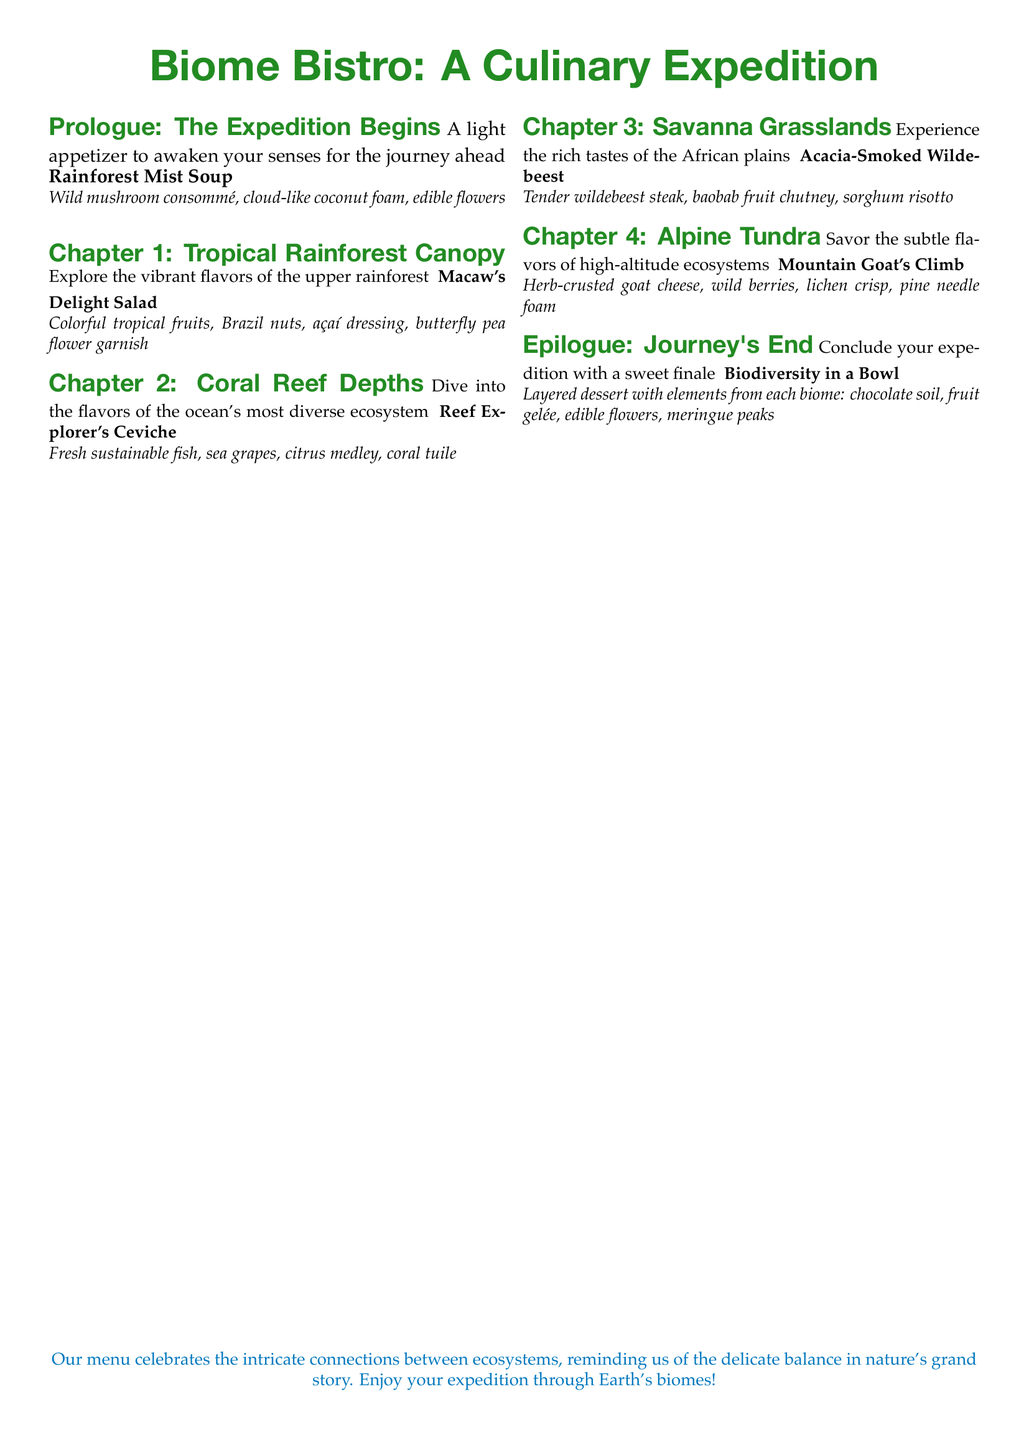What is the title of the menu? The title of the menu is presented in a large font at the beginning of the document.
Answer: Biome Bistro: A Culinary Expedition How many chapters are in the menu? The menu includes five main sections: one prologue, four chapters, and an epilogue.
Answer: 4 What is the dish in the prologue? The dish listed under the prologue section serves as an introduction to the menu.
Answer: Rainforest Mist Soup What is the main ingredient in the dish "Acacia-Smoked Wildebeest"? The dish named "Acacia-Smoked Wildebeest" features a specific type of meat as its primary ingredient.
Answer: Wildebeest Which chapter features a layered dessert? The dessert is presented in the final section of the menu that concludes the dining experience.
Answer: Epilogue What fruit is mentioned in the "Macaw's Delight Salad"? The salad includes a variety of tropical fruits as part of its ingredients, indicated in the description.
Answer: Tropical fruits What color theme is used for the header of the menu? The header uses a specific color to enhance its visual appeal, which can be identified in the document.
Answer: Forest green What is the last dish served in the menu? The last dish described in the menu concludes the dining journey with a sweet element.
Answer: Biodiversity in a Bowl 